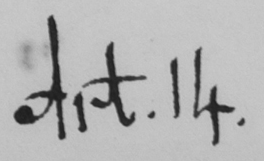Please transcribe the handwritten text in this image. Art . 14 . 